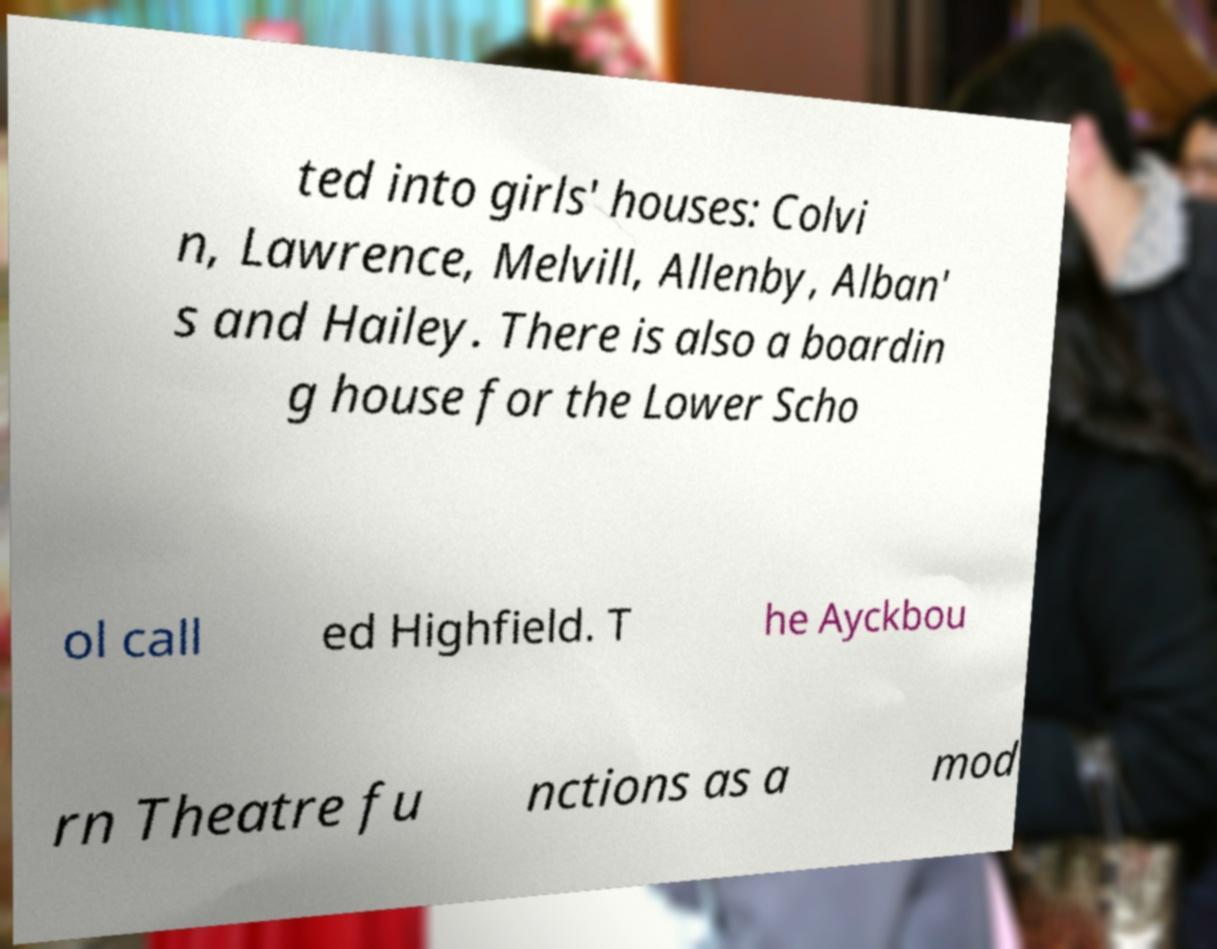There's text embedded in this image that I need extracted. Can you transcribe it verbatim? ted into girls' houses: Colvi n, Lawrence, Melvill, Allenby, Alban' s and Hailey. There is also a boardin g house for the Lower Scho ol call ed Highfield. T he Ayckbou rn Theatre fu nctions as a mod 